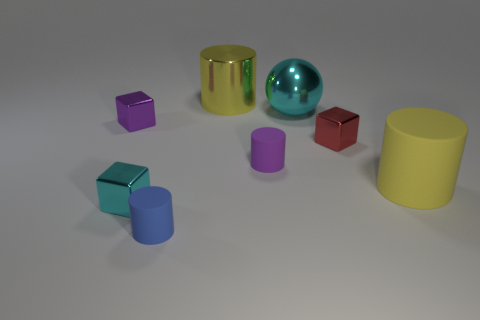There is a large thing that is the same color as the big metal cylinder; what material is it?
Your answer should be very brief. Rubber. Is the color of the sphere the same as the small block that is in front of the purple rubber object?
Ensure brevity in your answer.  Yes. Are there more small purple rubber objects than purple objects?
Keep it short and to the point. No. What size is the purple thing that is the same shape as the blue rubber object?
Make the answer very short. Small. Does the purple cylinder have the same material as the yellow cylinder in front of the small purple cylinder?
Give a very brief answer. Yes. How many things are blue matte cylinders or small green metal objects?
Your answer should be compact. 1. There is a metallic block in front of the tiny red object; is its size the same as the shiny cube that is right of the small blue rubber thing?
Your answer should be compact. Yes. What number of blocks are either red shiny things or tiny cyan objects?
Provide a short and direct response. 2. Are any large gray metallic cylinders visible?
Ensure brevity in your answer.  No. Is there anything else that is the same shape as the large cyan shiny thing?
Provide a succinct answer. No. 